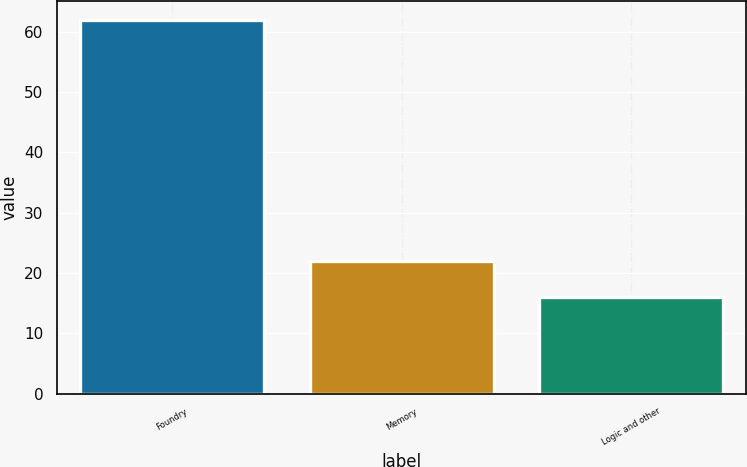<chart> <loc_0><loc_0><loc_500><loc_500><bar_chart><fcel>Foundry<fcel>Memory<fcel>Logic and other<nl><fcel>62<fcel>22<fcel>16<nl></chart> 